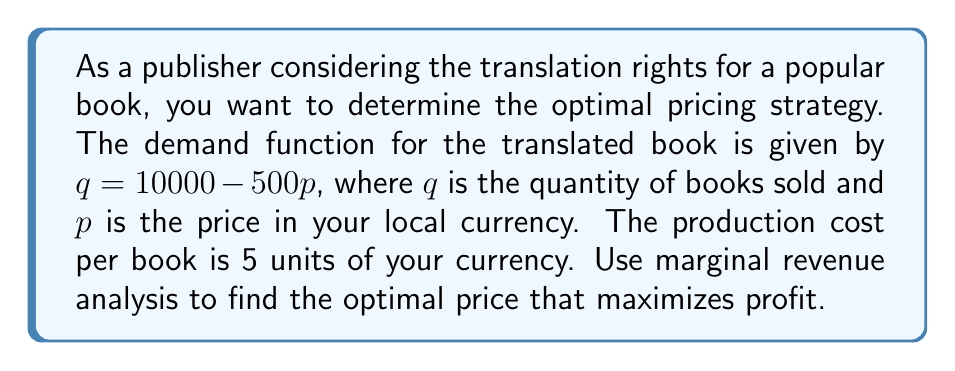Show me your answer to this math problem. 1. First, we need to find the revenue function $R(q)$:
   From the demand function, we can express $p$ in terms of $q$:
   $q = 10000 - 500p$
   $500p = 10000 - q$
   $p = 20 - \frac{q}{250}$
   
   Revenue $R(q) = pq = (20 - \frac{q}{250})q = 20q - \frac{q^2}{250}$

2. Now, we find the marginal revenue function $MR(q)$ by taking the derivative of $R(q)$:
   $MR(q) = \frac{dR}{dq} = 20 - \frac{2q}{250} = 20 - \frac{q}{125}$

3. The marginal cost (MC) is constant at 5 units of currency per book.

4. For profit maximization, we set $MR = MC$:
   $20 - \frac{q}{125} = 5$
   $15 = \frac{q}{125}$
   $q = 1875$

5. Now we can find the optimal price by substituting this quantity back into our demand function:
   $1875 = 10000 - 500p$
   $500p = 8125$
   $p = 16.25$

6. To verify this is a maximum (not minimum), we can check that $MR$ is decreasing at this point:
   $\frac{dMR}{dq} = -\frac{1}{125} < 0$, confirming a maximum.
Answer: The optimal price is 16.25 units of the local currency. 